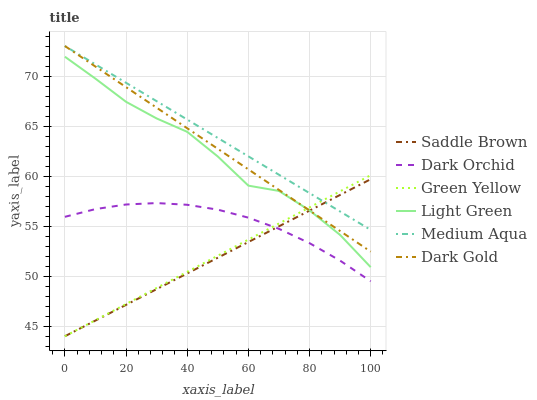Does Dark Orchid have the minimum area under the curve?
Answer yes or no. No. Does Dark Orchid have the maximum area under the curve?
Answer yes or no. No. Is Dark Orchid the smoothest?
Answer yes or no. No. Is Dark Orchid the roughest?
Answer yes or no. No. Does Dark Orchid have the lowest value?
Answer yes or no. No. Does Dark Orchid have the highest value?
Answer yes or no. No. Is Light Green less than Medium Aqua?
Answer yes or no. Yes. Is Medium Aqua greater than Dark Orchid?
Answer yes or no. Yes. Does Light Green intersect Medium Aqua?
Answer yes or no. No. 